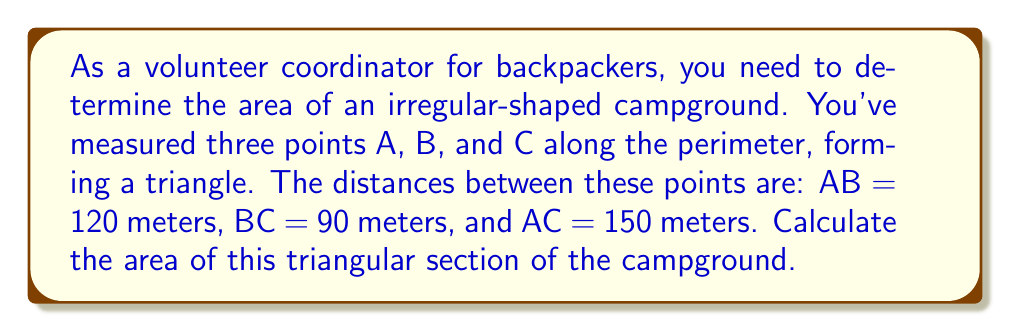Solve this math problem. To solve this problem, we'll use Heron's formula for the area of a triangle given its side lengths.

Step 1: Calculate the semi-perimeter (s)
The semi-perimeter is half the perimeter of the triangle.
$$s = \frac{a + b + c}{2}$$
Where a, b, and c are the side lengths of the triangle.

$$s = \frac{120 + 90 + 150}{2} = \frac{360}{2} = 180\text{ meters}$$

Step 2: Apply Heron's formula
Heron's formula states that the area (A) of a triangle with semi-perimeter s and side lengths a, b, and c is:

$$A = \sqrt{s(s-a)(s-b)(s-c)}$$

Substituting our values:

$$A = \sqrt{180(180-120)(180-90)(180-150)}$$
$$A = \sqrt{180 \cdot 60 \cdot 90 \cdot 30}$$
$$A = \sqrt{29,160,000}$$
$$A = 5,400\text{ square meters}$$

[asy]
unitsize(0.03cm);
pair A = (0,0), B = (120,0), C = (60,90);
draw(A--B--C--A);
label("A", A, SW);
label("B", B, SE);
label("C", C, N);
label("120m", (A+B)/2, S);
label("90m", (B+C)/2, NE);
label("150m", (A+C)/2, NW);
[/asy]
Answer: 5,400 square meters 